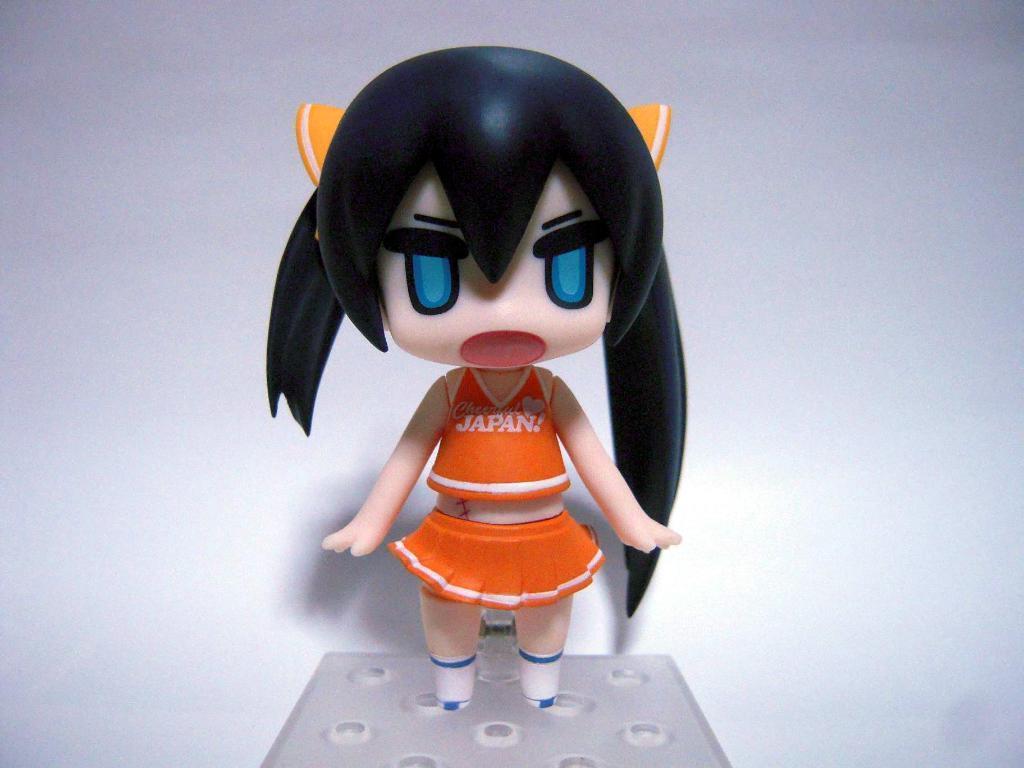Describe this image in one or two sentences. In this image we can see one toy and there is a white color background. 